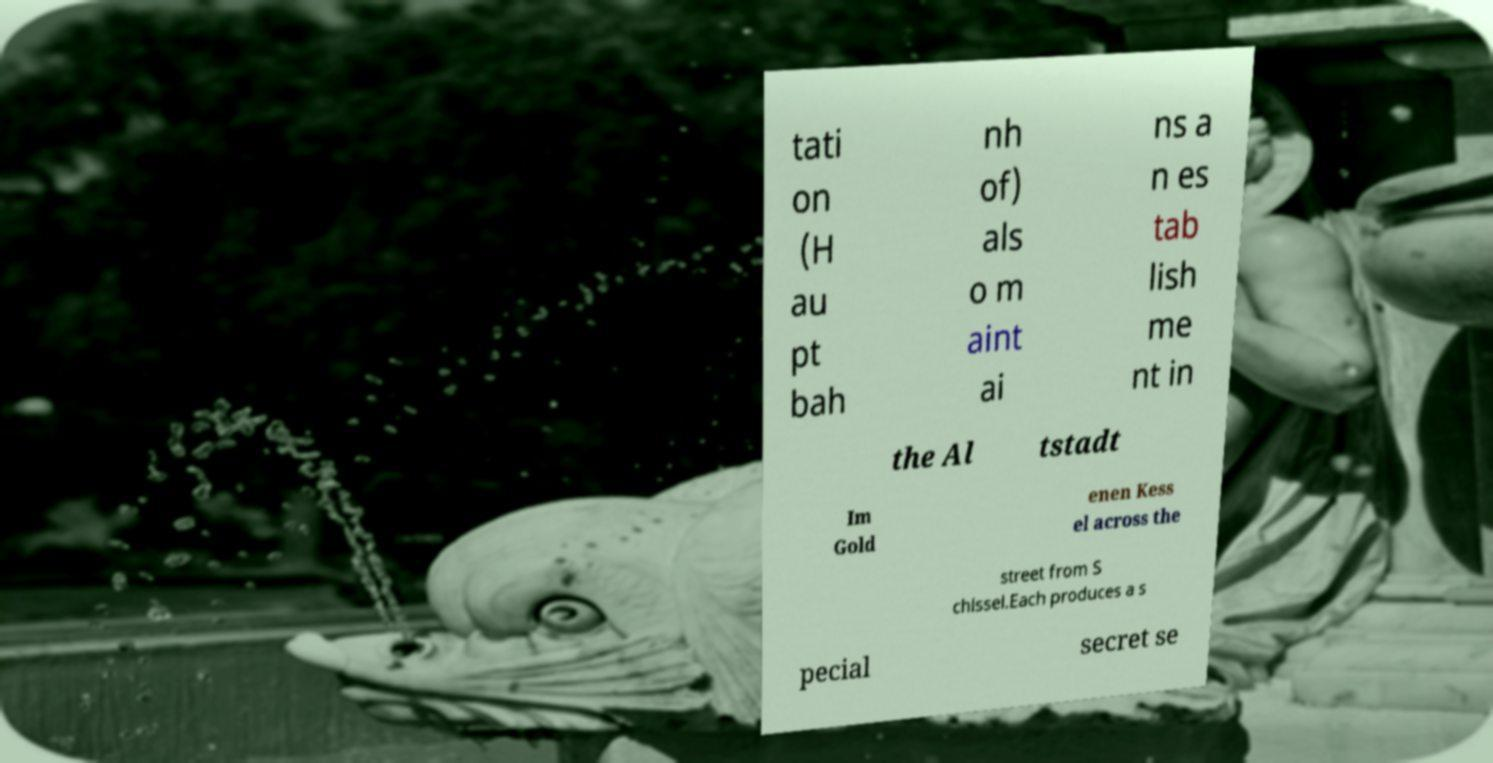Please identify and transcribe the text found in this image. tati on (H au pt bah nh of) als o m aint ai ns a n es tab lish me nt in the Al tstadt Im Gold enen Kess el across the street from S chlssel.Each produces a s pecial secret se 